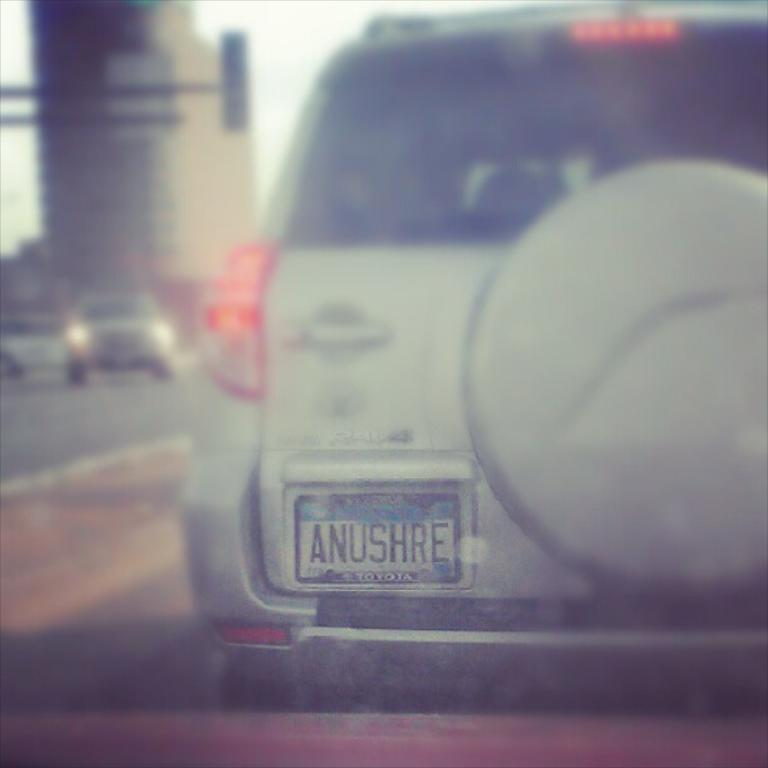<image>
Summarize the visual content of the image. A plate that has the letters ANUSHRE on it. 